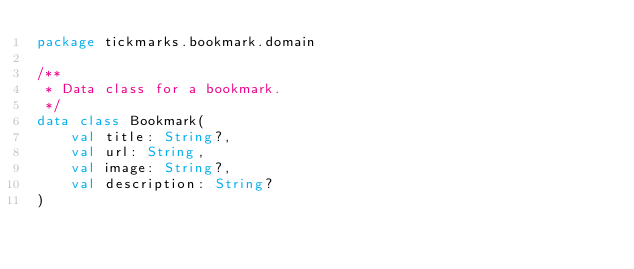<code> <loc_0><loc_0><loc_500><loc_500><_Kotlin_>package tickmarks.bookmark.domain

/**
 * Data class for a bookmark.
 */
data class Bookmark(
    val title: String?,
    val url: String,
    val image: String?,
    val description: String?
)
</code> 